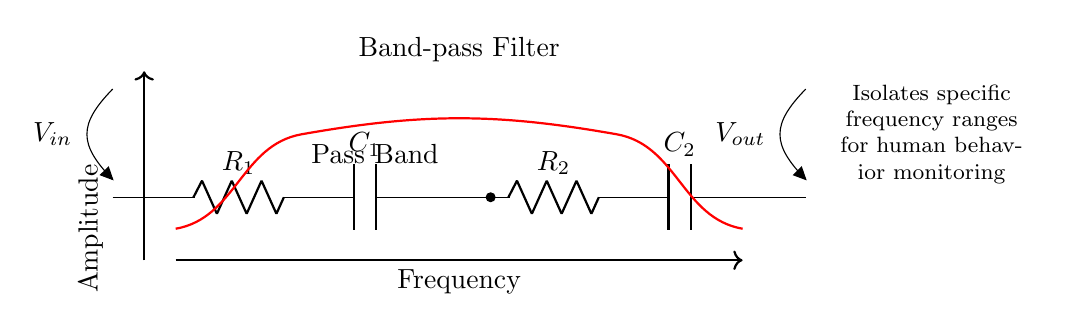What components are present in the circuit? The circuit contains two resistors (R1, R2) and two capacitors (C1, C2). Each component can be identified by their respective labels in the diagram.
Answer: Resistors and capacitors What is the output voltage reference point in the circuit? The output voltage is referenced at point 11 in the circuit, which is labeled as Vout. It is directly connected to the last capacitor and annotated in the diagram.
Answer: Vout What is the function of the highlighted 'Pass Band' in the diagram? The 'Pass Band' indicates the range of frequencies that the band-pass filter allows to pass through while attenuating others. This is visually represented in the diagram where the red line shows the frequencies within the pass band.
Answer: Isolates specific frequencies How many stages does the band-pass filter have? The diagram shows two main stages: one stage involves R1 and C1, while the second stage involves R2 and C2. Each stage contributes to the filtering process.
Answer: Two stages What type of filter is represented in the diagram? The type of filter depicted is a band-pass filter, which is explicitly labeled in the diagram and functions to isolate a specific frequency range.
Answer: Band-pass filter What does the thick red line represent in the frequency response? The thick red line indicates the amplitude response of the filter across frequencies, showcasing how the filter behaves at different frequencies—passing those within the pass band and attenuating others.
Answer: Amplitude response 